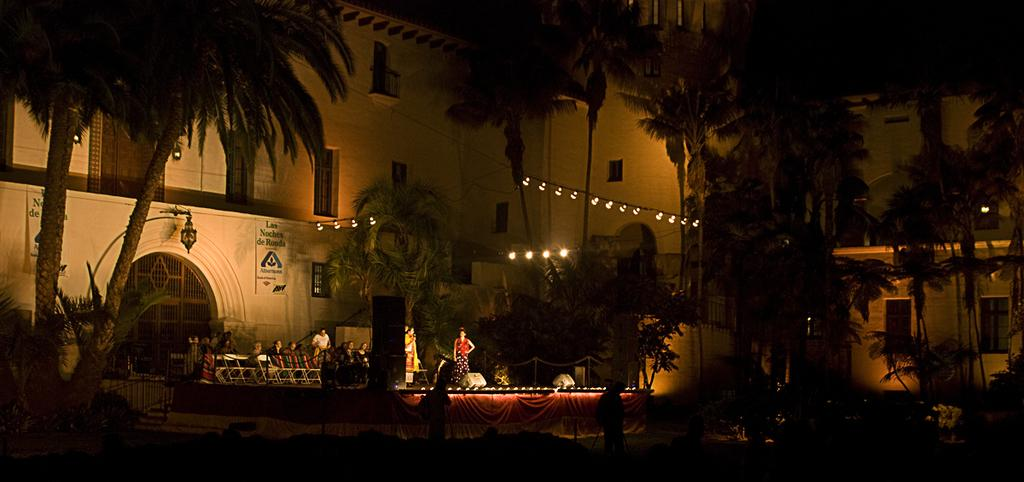How many people are in the image? There are people in the image, but the exact number is not specified. What type of furniture is present in the image? There are chairs in the image. What type of audio equipment is present in the image? There are speakers in the image. What type of decorative or informational items are present in the image? There are banners in the image. What type of natural elements are present in the image? There are trees in the image. What type of textile is present in the image? There is cloth in the image. What type of lighting is present in the image? There are lights in the image. What type of structures are present in the image? There are buildings with windows in the image. Can you see a goat grazing in the image? No, there is no goat present in the image. What type of tin is being used to hold the unspecified objects in the image? There is no tin present in the image, and the unspecified objects are not described in detail. 